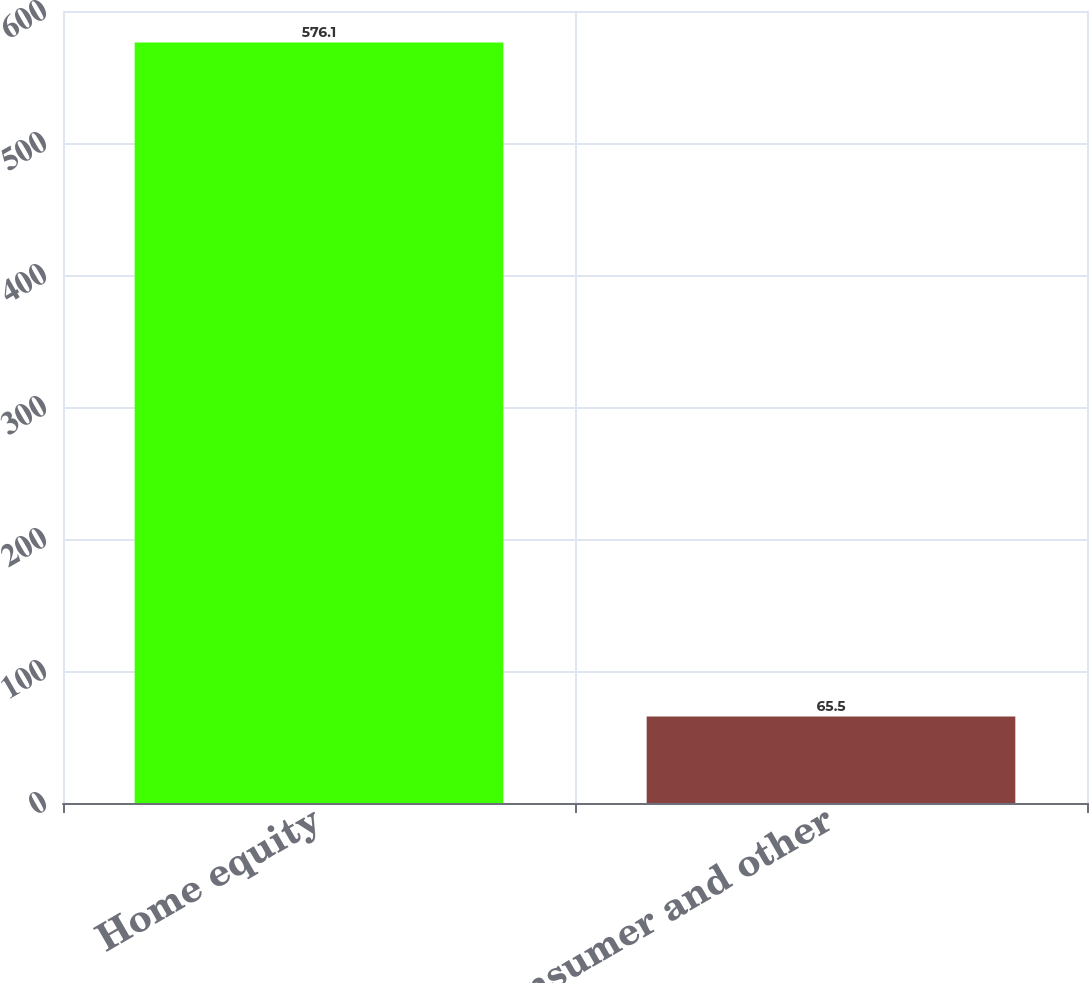<chart> <loc_0><loc_0><loc_500><loc_500><bar_chart><fcel>Home equity<fcel>Consumer and other<nl><fcel>576.1<fcel>65.5<nl></chart> 